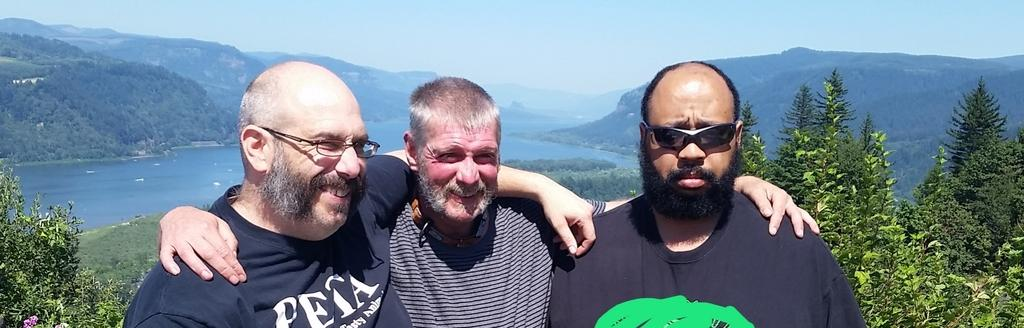How many people are present in the image? There are three people in the image. What can be observed about the appearance of two of the people? Two of the people are wearing spectacles. What type of natural environment is visible in the background of the image? There are trees, water, mountains, and the sky visible in the background of the image. Where can the ants be seen crawling on the curtain in the image? There are no ants or curtains present in the image. What type of lake is visible in the image? There is no lake visible in the image; only water is present in the background. 